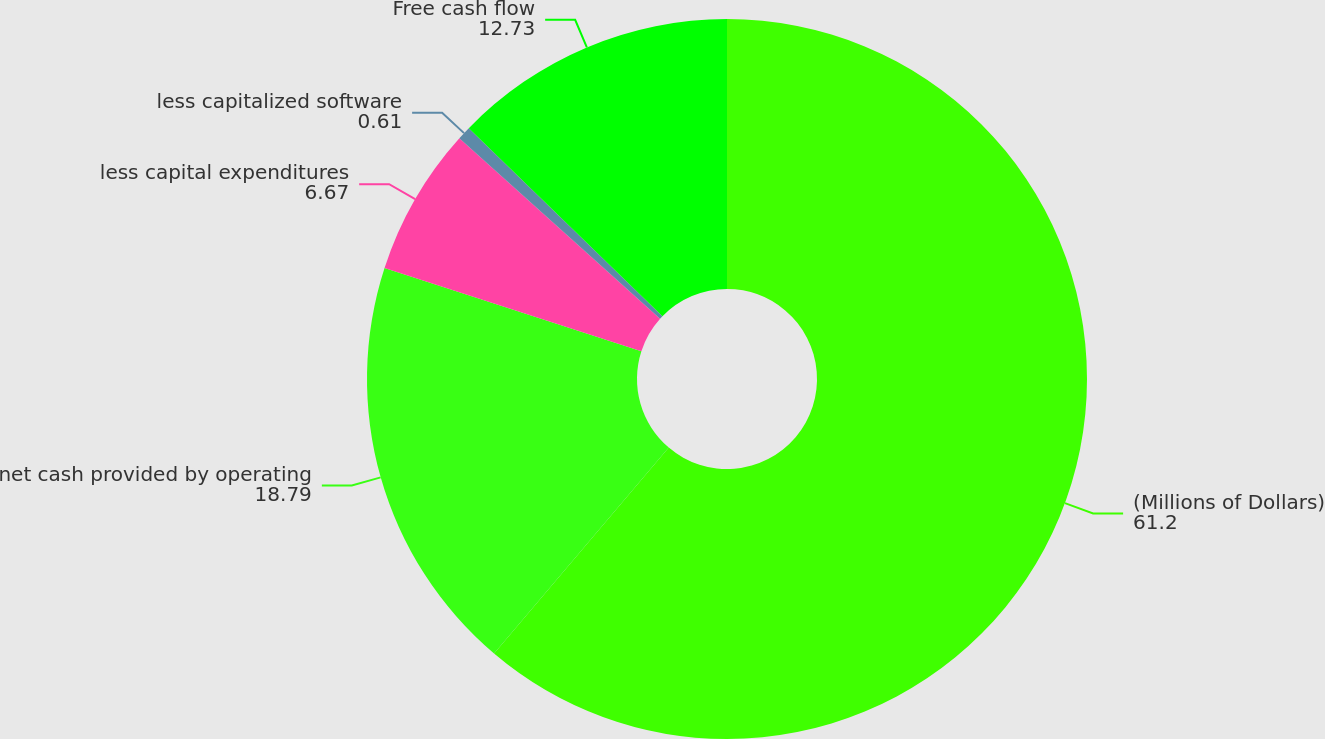Convert chart. <chart><loc_0><loc_0><loc_500><loc_500><pie_chart><fcel>(Millions of Dollars)<fcel>net cash provided by operating<fcel>less capital expenditures<fcel>less capitalized software<fcel>Free cash flow<nl><fcel>61.2%<fcel>18.79%<fcel>6.67%<fcel>0.61%<fcel>12.73%<nl></chart> 